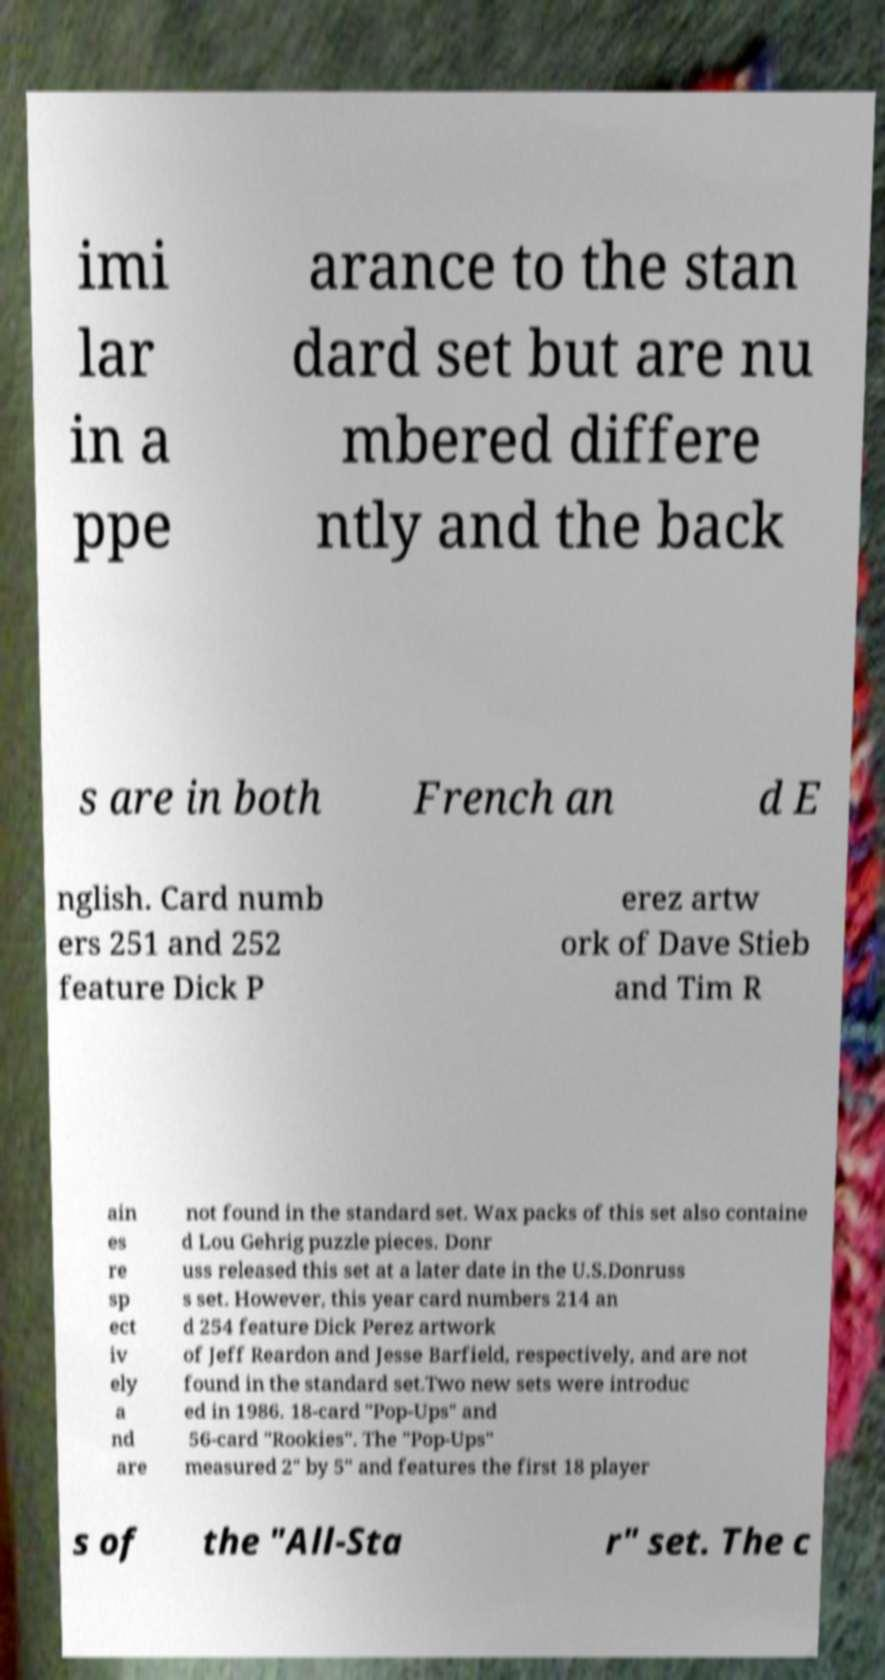Please read and relay the text visible in this image. What does it say? imi lar in a ppe arance to the stan dard set but are nu mbered differe ntly and the back s are in both French an d E nglish. Card numb ers 251 and 252 feature Dick P erez artw ork of Dave Stieb and Tim R ain es re sp ect iv ely a nd are not found in the standard set. Wax packs of this set also containe d Lou Gehrig puzzle pieces. Donr uss released this set at a later date in the U.S.Donruss s set. However, this year card numbers 214 an d 254 feature Dick Perez artwork of Jeff Reardon and Jesse Barfield, respectively, and are not found in the standard set.Two new sets were introduc ed in 1986. 18-card "Pop-Ups" and 56-card "Rookies". The "Pop-Ups" measured 2" by 5" and features the first 18 player s of the "All-Sta r" set. The c 